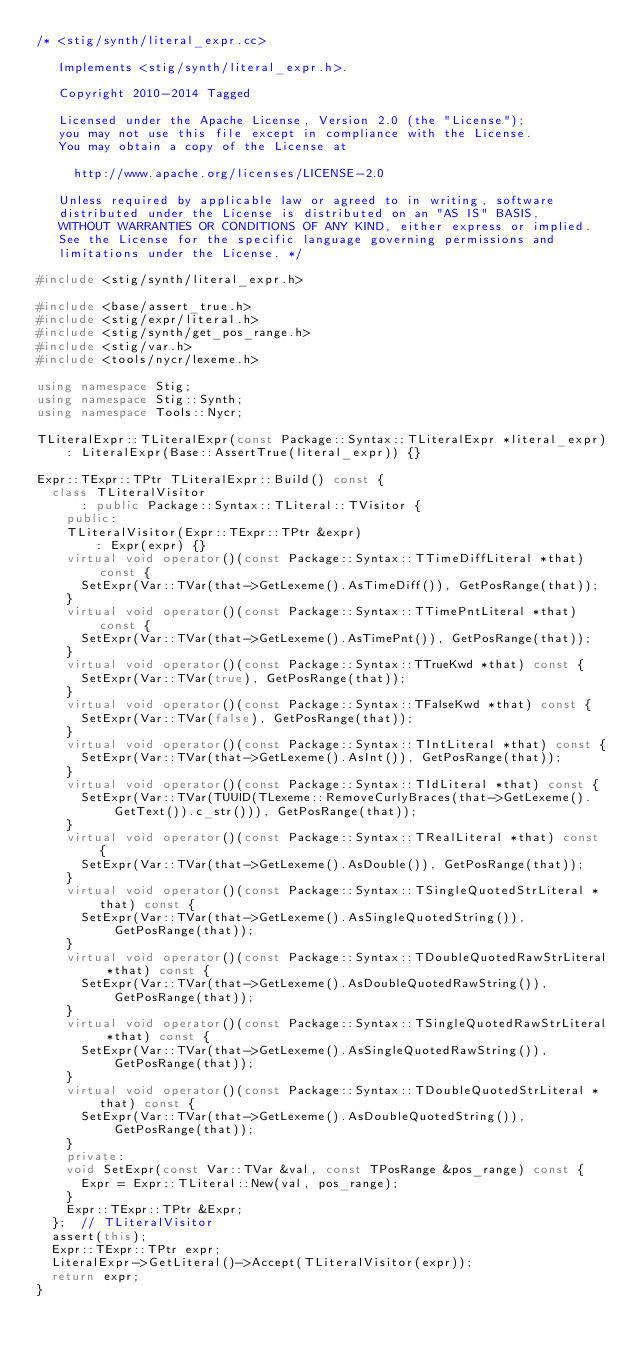Convert code to text. <code><loc_0><loc_0><loc_500><loc_500><_C++_>/* <stig/synth/literal_expr.cc> 

   Implements <stig/synth/literal_expr.h>.

   Copyright 2010-2014 Tagged
   
   Licensed under the Apache License, Version 2.0 (the "License");
   you may not use this file except in compliance with the License.
   You may obtain a copy of the License at
   
     http://www.apache.org/licenses/LICENSE-2.0
   
   Unless required by applicable law or agreed to in writing, software
   distributed under the License is distributed on an "AS IS" BASIS,
   WITHOUT WARRANTIES OR CONDITIONS OF ANY KIND, either express or implied.
   See the License for the specific language governing permissions and
   limitations under the License. */

#include <stig/synth/literal_expr.h>

#include <base/assert_true.h>
#include <stig/expr/literal.h>
#include <stig/synth/get_pos_range.h>
#include <stig/var.h>
#include <tools/nycr/lexeme.h>

using namespace Stig;
using namespace Stig::Synth;
using namespace Tools::Nycr;

TLiteralExpr::TLiteralExpr(const Package::Syntax::TLiteralExpr *literal_expr)
    : LiteralExpr(Base::AssertTrue(literal_expr)) {}

Expr::TExpr::TPtr TLiteralExpr::Build() const {
  class TLiteralVisitor
      : public Package::Syntax::TLiteral::TVisitor {
    public:
    TLiteralVisitor(Expr::TExpr::TPtr &expr)
        : Expr(expr) {}
    virtual void operator()(const Package::Syntax::TTimeDiffLiteral *that) const {
      SetExpr(Var::TVar(that->GetLexeme().AsTimeDiff()), GetPosRange(that));
    }
    virtual void operator()(const Package::Syntax::TTimePntLiteral *that) const {
      SetExpr(Var::TVar(that->GetLexeme().AsTimePnt()), GetPosRange(that));
    }
    virtual void operator()(const Package::Syntax::TTrueKwd *that) const {
      SetExpr(Var::TVar(true), GetPosRange(that));
    }
    virtual void operator()(const Package::Syntax::TFalseKwd *that) const {
      SetExpr(Var::TVar(false), GetPosRange(that));
    }
    virtual void operator()(const Package::Syntax::TIntLiteral *that) const {
      SetExpr(Var::TVar(that->GetLexeme().AsInt()), GetPosRange(that));
    }
    virtual void operator()(const Package::Syntax::TIdLiteral *that) const {
      SetExpr(Var::TVar(TUUID(TLexeme::RemoveCurlyBraces(that->GetLexeme().GetText()).c_str())), GetPosRange(that));
    }
    virtual void operator()(const Package::Syntax::TRealLiteral *that) const {
      SetExpr(Var::TVar(that->GetLexeme().AsDouble()), GetPosRange(that));
    }
    virtual void operator()(const Package::Syntax::TSingleQuotedStrLiteral *that) const {
      SetExpr(Var::TVar(that->GetLexeme().AsSingleQuotedString()), GetPosRange(that));
    }
    virtual void operator()(const Package::Syntax::TDoubleQuotedRawStrLiteral *that) const {
      SetExpr(Var::TVar(that->GetLexeme().AsDoubleQuotedRawString()), GetPosRange(that));
    }
    virtual void operator()(const Package::Syntax::TSingleQuotedRawStrLiteral *that) const {
      SetExpr(Var::TVar(that->GetLexeme().AsSingleQuotedRawString()), GetPosRange(that));
    }
    virtual void operator()(const Package::Syntax::TDoubleQuotedStrLiteral *that) const {
      SetExpr(Var::TVar(that->GetLexeme().AsDoubleQuotedString()), GetPosRange(that));
    }
    private:
    void SetExpr(const Var::TVar &val, const TPosRange &pos_range) const {
      Expr = Expr::TLiteral::New(val, pos_range);
    }
    Expr::TExpr::TPtr &Expr;
  };  // TLiteralVisitor
  assert(this);
  Expr::TExpr::TPtr expr;
  LiteralExpr->GetLiteral()->Accept(TLiteralVisitor(expr));
  return expr;
}

</code> 